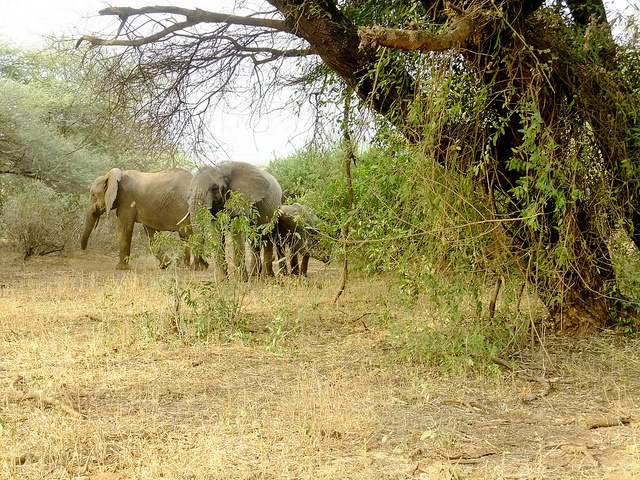Describe the objects in this image and their specific colors. I can see elephant in white, olive, and tan tones, elephant in white, olive, and gray tones, and elephant in white, black, and olive tones in this image. 